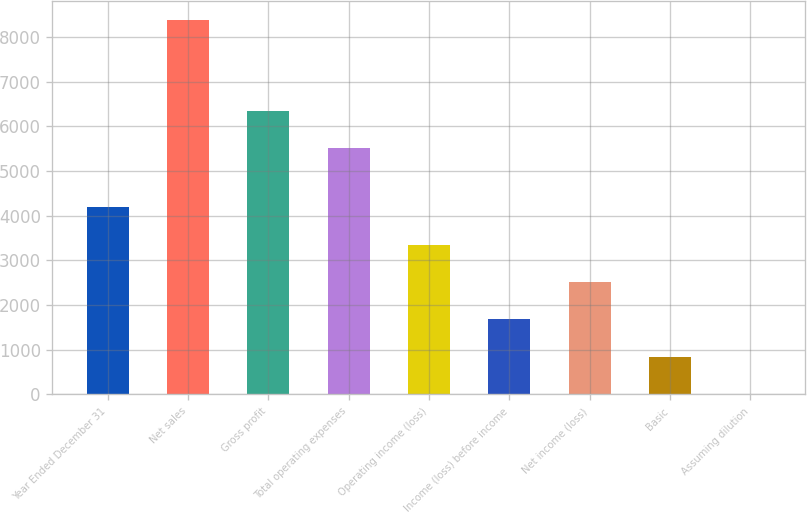Convert chart. <chart><loc_0><loc_0><loc_500><loc_500><bar_chart><fcel>Year Ended December 31<fcel>Net sales<fcel>Gross profit<fcel>Total operating expenses<fcel>Operating income (loss)<fcel>Income (loss) before income<fcel>Net income (loss)<fcel>Basic<fcel>Assuming dilution<nl><fcel>4193.14<fcel>8386<fcel>6353.57<fcel>5515<fcel>3354.56<fcel>1677.41<fcel>2515.99<fcel>838.83<fcel>0.25<nl></chart> 